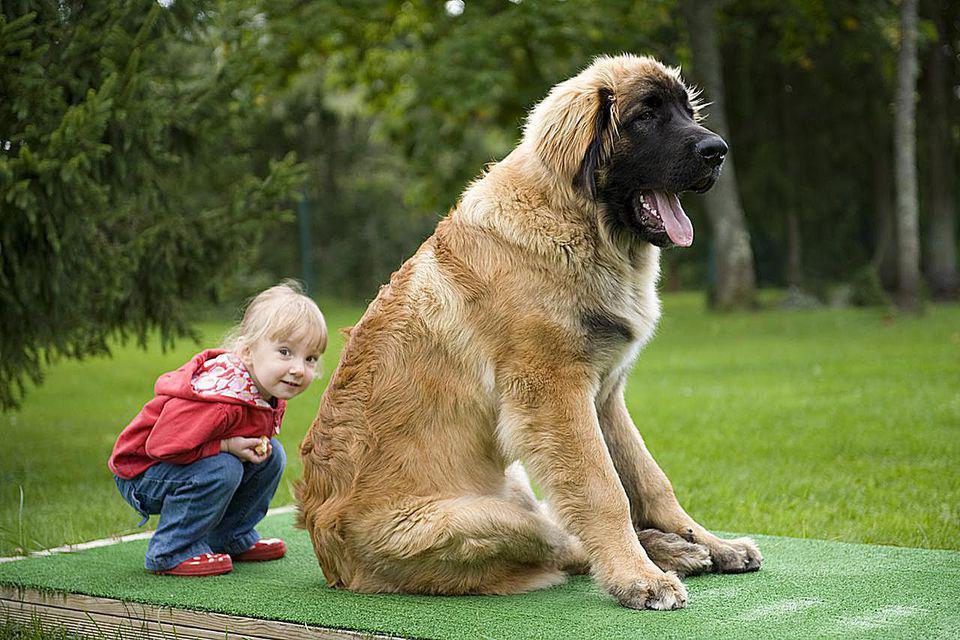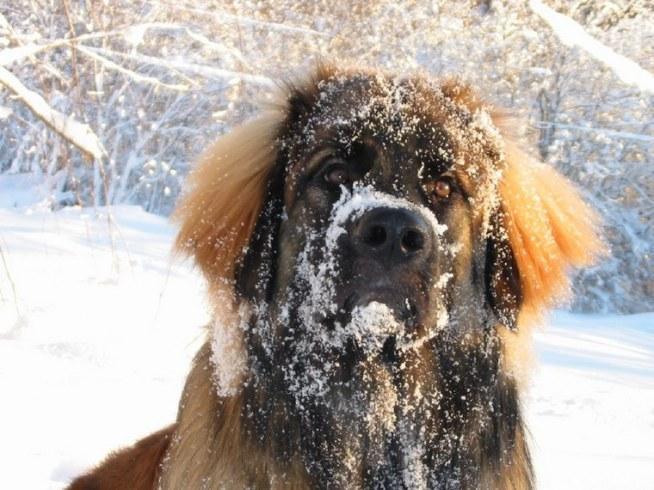The first image is the image on the left, the second image is the image on the right. For the images displayed, is the sentence "An image shows a toddler girl next to a large dog." factually correct? Answer yes or no. Yes. 